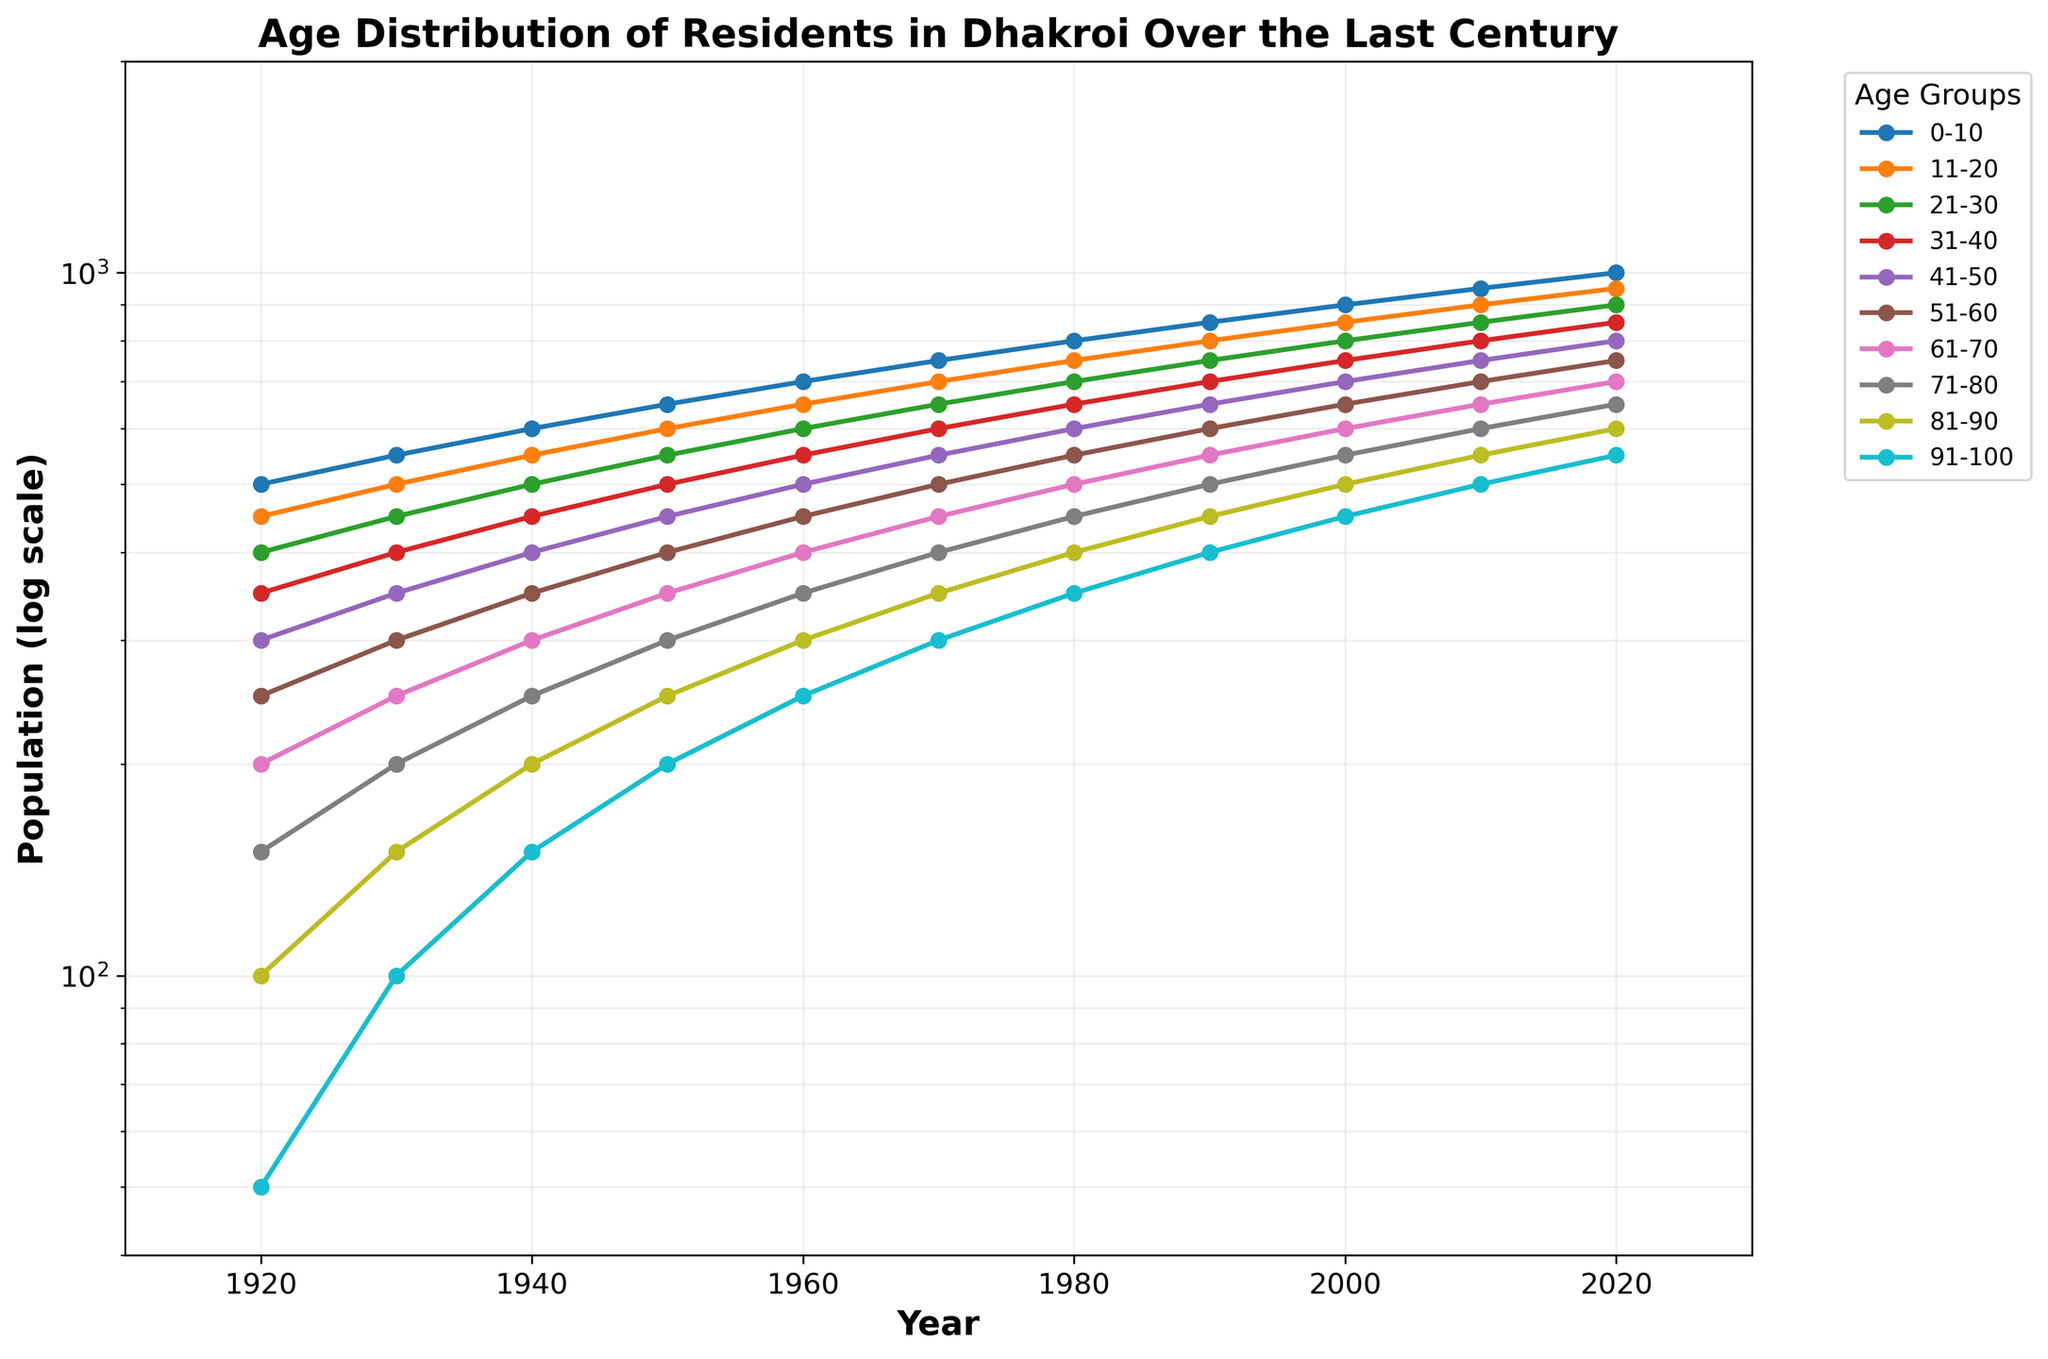What is the title of the figure? The title is usually located at the top of the figure. It is written in bold and typically summarizes the information contained in the plot.
Answer: Age Distribution of Residents in Dhakroi Over the Last Century What are the units on the y-axis? The y-axis is labeled on the left side of the plot, specifying the measure being represented. In this case, it describes the population using a log scale.
Answer: Population (log scale) Which age group has the highest population in the year 2020? To find this, look at the data points for the year 2020 and see which one is the highest.
Answer: 0-10 In which years does the age group 51-60 exceed a population of 500? You need to trace the line for the age group 51-60 and identify the years when its value is above the 500 mark on the y-axis.
Answer: From 1960 to 2020 How did the population of the age group 31-40 change from 1920 to 2020? Look at the data points for the age group 31-40 in the years 1920 and 2020, and note the difference in values.
Answer: Increased by 500 Which age group has the smallest population change from 1920 to 2020? Compare the population values of each age group from 1920 to 2020 and see which age group has the smallest difference.
Answer: 91-100 What can you say about the overall trend of the population across all age groups over the century? Observe the general direction of the lines across all age groups from 1920 to 2020 to determine if they are increasing, decreasing, or stable.
Answer: Increasing For the year 1950, which two age groups have the closest population values? Look at the data points for the year 1950 and compare the differences between them to find the two that are closest.
Answer: 31-40 and 41-50 Looking at the log scale on the y-axis, how does it affect the interpretation of population changes? The log scale means each step on the y-axis represents a multiplication factor, not an addition. This helps to visualize both small and large population changes more effectively.
Answer: It compresses large ranges, making comparisons of growth rates easier 